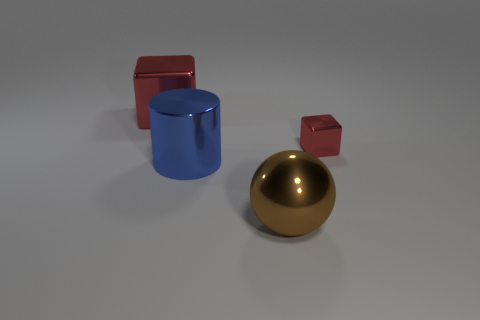What number of big things are blue matte cylinders or cubes? In the image, there is one large blue matte cylinder. 